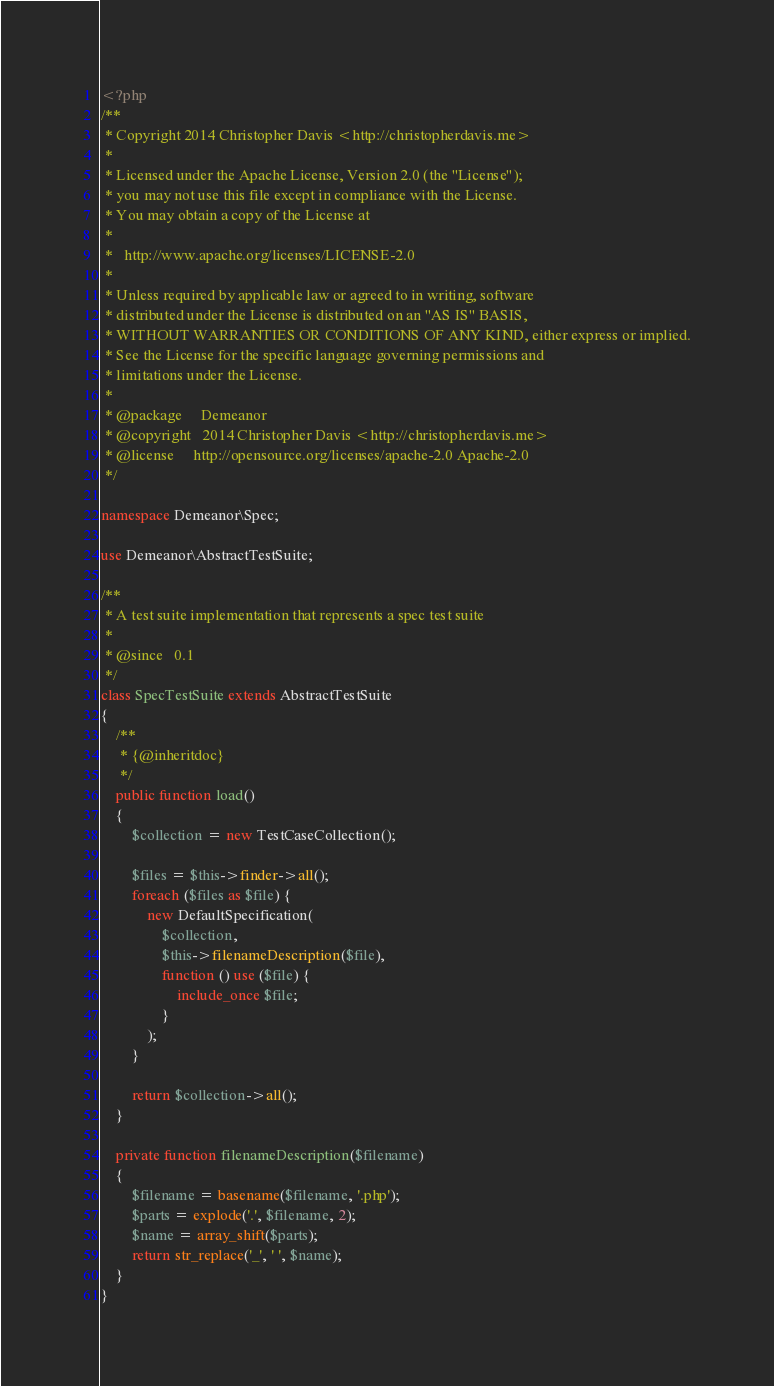<code> <loc_0><loc_0><loc_500><loc_500><_PHP_><?php
/**
 * Copyright 2014 Christopher Davis <http://christopherdavis.me>
 *
 * Licensed under the Apache License, Version 2.0 (the "License");
 * you may not use this file except in compliance with the License.
 * You may obtain a copy of the License at
 *
 *   http://www.apache.org/licenses/LICENSE-2.0
 *
 * Unless required by applicable law or agreed to in writing, software
 * distributed under the License is distributed on an "AS IS" BASIS,
 * WITHOUT WARRANTIES OR CONDITIONS OF ANY KIND, either express or implied.
 * See the License for the specific language governing permissions and
 * limitations under the License.
 *
 * @package     Demeanor
 * @copyright   2014 Christopher Davis <http://christopherdavis.me>
 * @license     http://opensource.org/licenses/apache-2.0 Apache-2.0
 */

namespace Demeanor\Spec;

use Demeanor\AbstractTestSuite;

/**
 * A test suite implementation that represents a spec test suite
 *
 * @since   0.1
 */
class SpecTestSuite extends AbstractTestSuite
{
    /**
     * {@inheritdoc}
     */
    public function load()
    {
        $collection = new TestCaseCollection();

        $files = $this->finder->all();
        foreach ($files as $file) {
            new DefaultSpecification(
                $collection,
                $this->filenameDescription($file),
                function () use ($file) {
                    include_once $file;
                }
            );
        }

        return $collection->all();
    }

    private function filenameDescription($filename)
    {
        $filename = basename($filename, '.php');
        $parts = explode('.', $filename, 2);
        $name = array_shift($parts);
        return str_replace('_', ' ', $name);
    }
}
</code> 